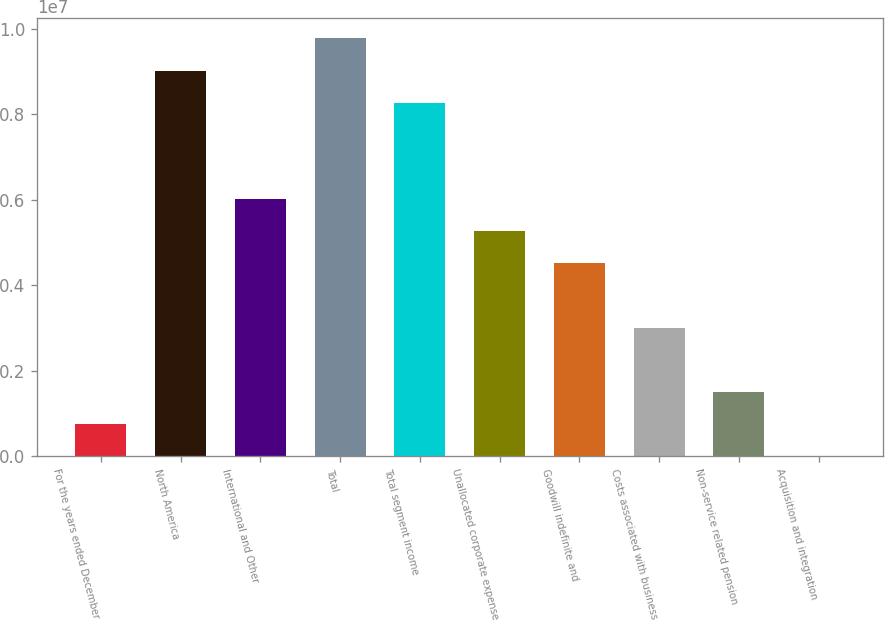Convert chart. <chart><loc_0><loc_0><loc_500><loc_500><bar_chart><fcel>For the years ended December<fcel>North America<fcel>International and Other<fcel>Total<fcel>Total segment income<fcel>Unallocated corporate expense<fcel>Goodwill indefinite and<fcel>Costs associated with business<fcel>Non-service related pension<fcel>Acquisition and integration<nl><fcel>751822<fcel>9.01845e+06<fcel>6.0124e+06<fcel>9.76996e+06<fcel>8.26694e+06<fcel>5.26089e+06<fcel>4.50938e+06<fcel>3.00636e+06<fcel>1.50333e+06<fcel>311<nl></chart> 